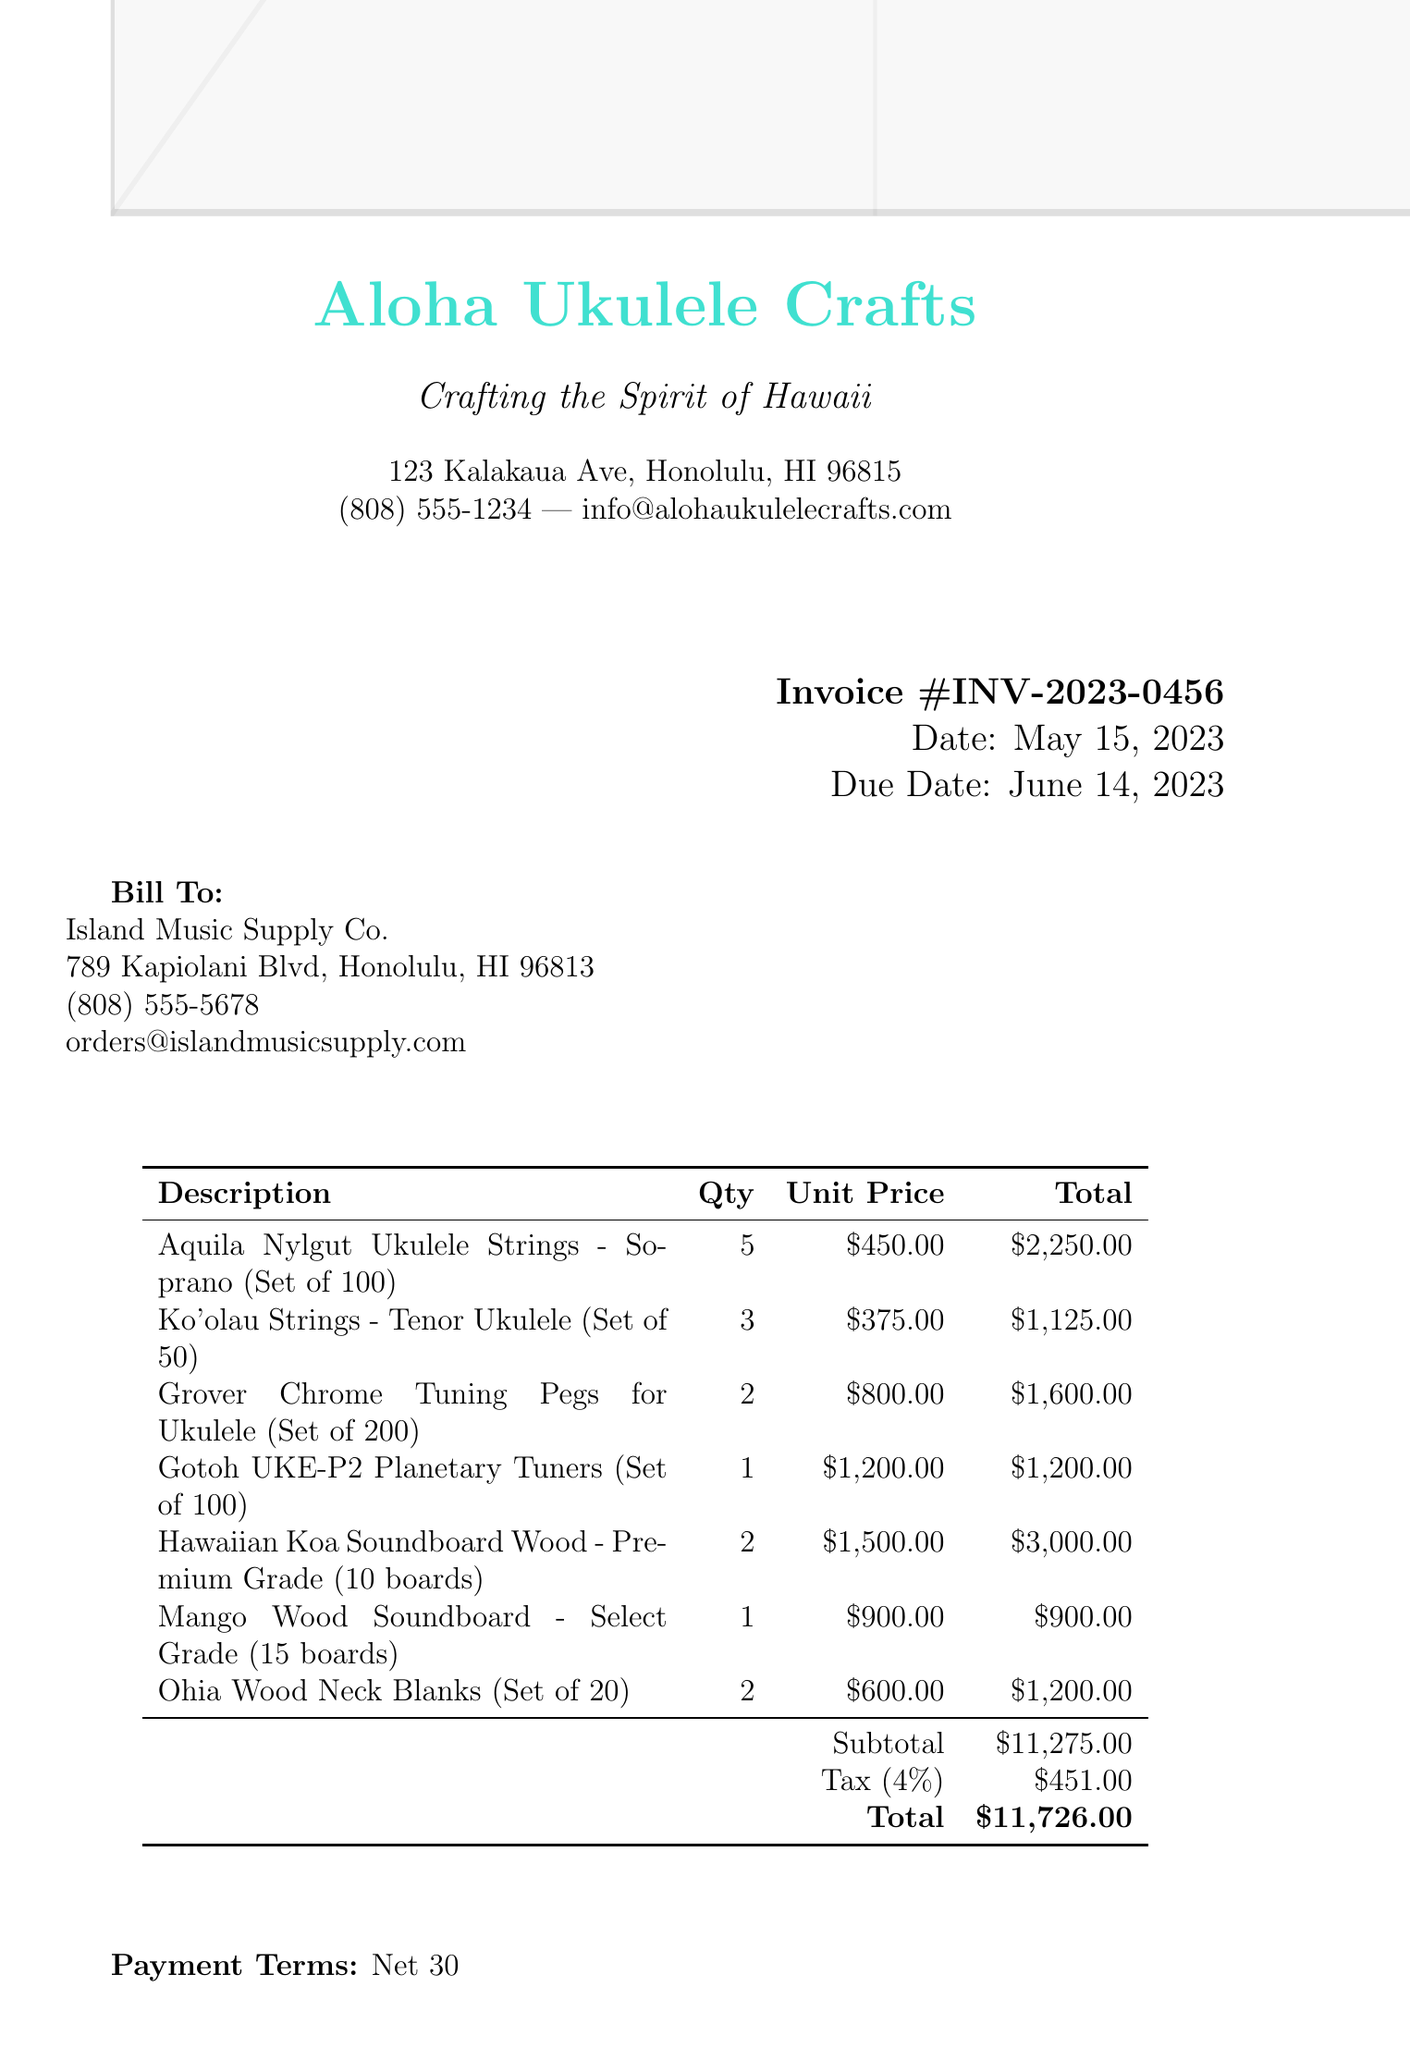What is the invoice number? The invoice number is listed in the document under the heading "Invoice" and is unique to this transaction.
Answer: INV-2023-0456 What is the due date for the invoice? The due date is specified in the document, indicating when payment is expected.
Answer: June 14, 2023 Who is the buyer for this invoice? The buyer's name is given in the "Bill To" section of the invoice.
Answer: Island Music Supply Co How many units of Grover Chrome Tuning Pegs are ordered? The quantity of Grover Chrome Tuning Pegs is stated in the itemized list of the invoice.
Answer: 2 What is the total amount due? The total amount due is calculated at the bottom of the invoice, including taxes.
Answer: $11,726.00 What is the subtotal before tax? The subtotal is the sum of all items before tax is applied, found in the totals section of the invoice.
Answer: $11,275.00 What is the tax rate applied to this invoice? The tax rate is specified in the totals area of the invoice, indicating what percentage has been added for tax.
Answer: 4% How many Hawaiian Koa Soundboard Wood boards are included in the order? The quantity of Hawaiian Koa Soundboard Wood is detailed in the items list of the invoice.
Answer: 2 What are the payment terms for this invoice? The payment terms explain the timeframe within which the payment should be made, noted in the document.
Answer: Net 30 